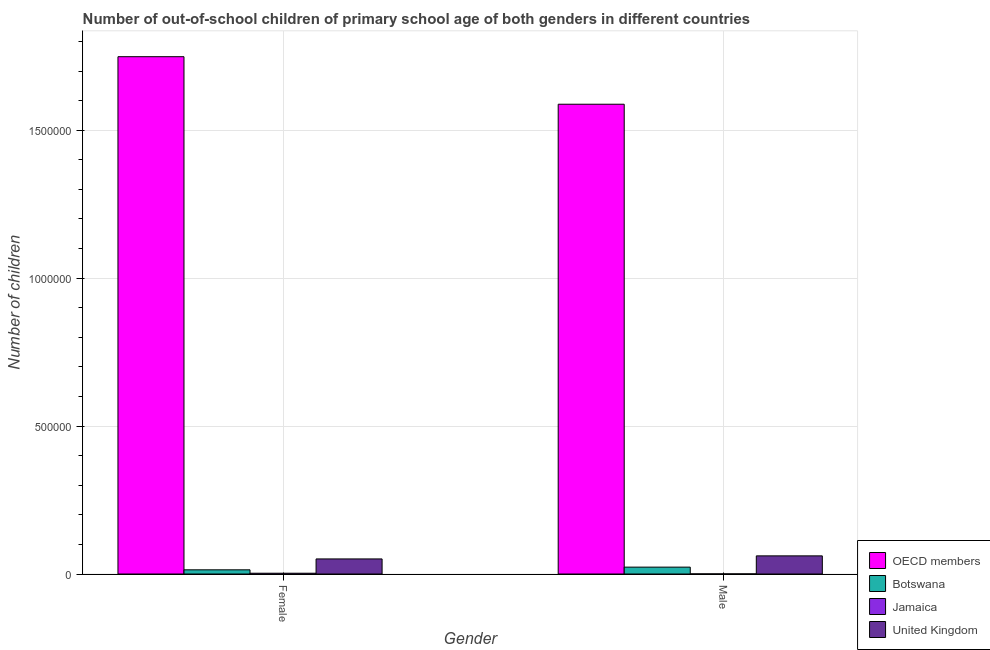Are the number of bars on each tick of the X-axis equal?
Offer a terse response. Yes. How many bars are there on the 2nd tick from the right?
Provide a succinct answer. 4. What is the number of female out-of-school students in Botswana?
Provide a short and direct response. 1.42e+04. Across all countries, what is the maximum number of female out-of-school students?
Provide a short and direct response. 1.75e+06. Across all countries, what is the minimum number of female out-of-school students?
Offer a terse response. 2619. In which country was the number of male out-of-school students maximum?
Ensure brevity in your answer.  OECD members. In which country was the number of female out-of-school students minimum?
Provide a short and direct response. Jamaica. What is the total number of female out-of-school students in the graph?
Offer a terse response. 1.82e+06. What is the difference between the number of male out-of-school students in United Kingdom and that in OECD members?
Provide a short and direct response. -1.53e+06. What is the difference between the number of female out-of-school students in Jamaica and the number of male out-of-school students in OECD members?
Make the answer very short. -1.59e+06. What is the average number of male out-of-school students per country?
Make the answer very short. 4.18e+05. What is the difference between the number of male out-of-school students and number of female out-of-school students in United Kingdom?
Your response must be concise. 1.03e+04. What is the ratio of the number of female out-of-school students in OECD members to that in Jamaica?
Provide a short and direct response. 667.6. Is the number of female out-of-school students in Jamaica less than that in United Kingdom?
Provide a short and direct response. Yes. What does the 3rd bar from the left in Female represents?
Provide a succinct answer. Jamaica. What does the 1st bar from the right in Male represents?
Your response must be concise. United Kingdom. What is the difference between two consecutive major ticks on the Y-axis?
Keep it short and to the point. 5.00e+05. Where does the legend appear in the graph?
Your answer should be very brief. Bottom right. How many legend labels are there?
Provide a succinct answer. 4. How are the legend labels stacked?
Your answer should be compact. Vertical. What is the title of the graph?
Your answer should be compact. Number of out-of-school children of primary school age of both genders in different countries. What is the label or title of the Y-axis?
Give a very brief answer. Number of children. What is the Number of children of OECD members in Female?
Offer a terse response. 1.75e+06. What is the Number of children in Botswana in Female?
Give a very brief answer. 1.42e+04. What is the Number of children of Jamaica in Female?
Your answer should be very brief. 2619. What is the Number of children of United Kingdom in Female?
Offer a terse response. 5.10e+04. What is the Number of children in OECD members in Male?
Offer a terse response. 1.59e+06. What is the Number of children in Botswana in Male?
Ensure brevity in your answer.  2.32e+04. What is the Number of children in Jamaica in Male?
Make the answer very short. 343. What is the Number of children in United Kingdom in Male?
Offer a terse response. 6.13e+04. Across all Gender, what is the maximum Number of children in OECD members?
Your answer should be compact. 1.75e+06. Across all Gender, what is the maximum Number of children in Botswana?
Provide a short and direct response. 2.32e+04. Across all Gender, what is the maximum Number of children of Jamaica?
Ensure brevity in your answer.  2619. Across all Gender, what is the maximum Number of children of United Kingdom?
Provide a succinct answer. 6.13e+04. Across all Gender, what is the minimum Number of children in OECD members?
Make the answer very short. 1.59e+06. Across all Gender, what is the minimum Number of children in Botswana?
Provide a short and direct response. 1.42e+04. Across all Gender, what is the minimum Number of children in Jamaica?
Make the answer very short. 343. Across all Gender, what is the minimum Number of children in United Kingdom?
Offer a very short reply. 5.10e+04. What is the total Number of children in OECD members in the graph?
Your answer should be very brief. 3.34e+06. What is the total Number of children of Botswana in the graph?
Your answer should be compact. 3.74e+04. What is the total Number of children of Jamaica in the graph?
Your answer should be very brief. 2962. What is the total Number of children in United Kingdom in the graph?
Make the answer very short. 1.12e+05. What is the difference between the Number of children in OECD members in Female and that in Male?
Keep it short and to the point. 1.61e+05. What is the difference between the Number of children of Botswana in Female and that in Male?
Keep it short and to the point. -9049. What is the difference between the Number of children of Jamaica in Female and that in Male?
Offer a very short reply. 2276. What is the difference between the Number of children of United Kingdom in Female and that in Male?
Your answer should be compact. -1.03e+04. What is the difference between the Number of children of OECD members in Female and the Number of children of Botswana in Male?
Provide a short and direct response. 1.73e+06. What is the difference between the Number of children in OECD members in Female and the Number of children in Jamaica in Male?
Keep it short and to the point. 1.75e+06. What is the difference between the Number of children of OECD members in Female and the Number of children of United Kingdom in Male?
Offer a very short reply. 1.69e+06. What is the difference between the Number of children of Botswana in Female and the Number of children of Jamaica in Male?
Offer a very short reply. 1.38e+04. What is the difference between the Number of children in Botswana in Female and the Number of children in United Kingdom in Male?
Give a very brief answer. -4.71e+04. What is the difference between the Number of children in Jamaica in Female and the Number of children in United Kingdom in Male?
Your response must be concise. -5.87e+04. What is the average Number of children of OECD members per Gender?
Your answer should be compact. 1.67e+06. What is the average Number of children in Botswana per Gender?
Ensure brevity in your answer.  1.87e+04. What is the average Number of children in Jamaica per Gender?
Provide a short and direct response. 1481. What is the average Number of children of United Kingdom per Gender?
Your answer should be very brief. 5.61e+04. What is the difference between the Number of children of OECD members and Number of children of Botswana in Female?
Offer a very short reply. 1.73e+06. What is the difference between the Number of children in OECD members and Number of children in Jamaica in Female?
Keep it short and to the point. 1.75e+06. What is the difference between the Number of children in OECD members and Number of children in United Kingdom in Female?
Make the answer very short. 1.70e+06. What is the difference between the Number of children of Botswana and Number of children of Jamaica in Female?
Make the answer very short. 1.15e+04. What is the difference between the Number of children of Botswana and Number of children of United Kingdom in Female?
Keep it short and to the point. -3.68e+04. What is the difference between the Number of children in Jamaica and Number of children in United Kingdom in Female?
Offer a terse response. -4.83e+04. What is the difference between the Number of children of OECD members and Number of children of Botswana in Male?
Offer a very short reply. 1.56e+06. What is the difference between the Number of children of OECD members and Number of children of Jamaica in Male?
Ensure brevity in your answer.  1.59e+06. What is the difference between the Number of children of OECD members and Number of children of United Kingdom in Male?
Provide a short and direct response. 1.53e+06. What is the difference between the Number of children of Botswana and Number of children of Jamaica in Male?
Offer a very short reply. 2.29e+04. What is the difference between the Number of children in Botswana and Number of children in United Kingdom in Male?
Your answer should be very brief. -3.81e+04. What is the difference between the Number of children of Jamaica and Number of children of United Kingdom in Male?
Offer a terse response. -6.10e+04. What is the ratio of the Number of children of OECD members in Female to that in Male?
Ensure brevity in your answer.  1.1. What is the ratio of the Number of children in Botswana in Female to that in Male?
Ensure brevity in your answer.  0.61. What is the ratio of the Number of children of Jamaica in Female to that in Male?
Make the answer very short. 7.64. What is the ratio of the Number of children of United Kingdom in Female to that in Male?
Your response must be concise. 0.83. What is the difference between the highest and the second highest Number of children of OECD members?
Offer a terse response. 1.61e+05. What is the difference between the highest and the second highest Number of children in Botswana?
Your answer should be very brief. 9049. What is the difference between the highest and the second highest Number of children of Jamaica?
Offer a very short reply. 2276. What is the difference between the highest and the second highest Number of children in United Kingdom?
Keep it short and to the point. 1.03e+04. What is the difference between the highest and the lowest Number of children in OECD members?
Ensure brevity in your answer.  1.61e+05. What is the difference between the highest and the lowest Number of children of Botswana?
Ensure brevity in your answer.  9049. What is the difference between the highest and the lowest Number of children in Jamaica?
Your response must be concise. 2276. What is the difference between the highest and the lowest Number of children in United Kingdom?
Ensure brevity in your answer.  1.03e+04. 